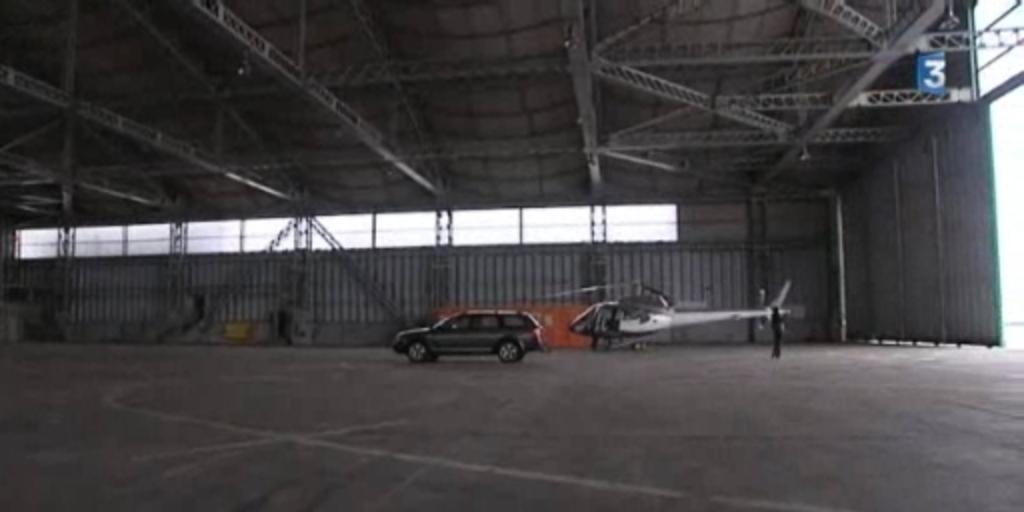<image>
Provide a brief description of the given image. An SUV and a helicopter are sitting inside a large empty hangar number 3. 